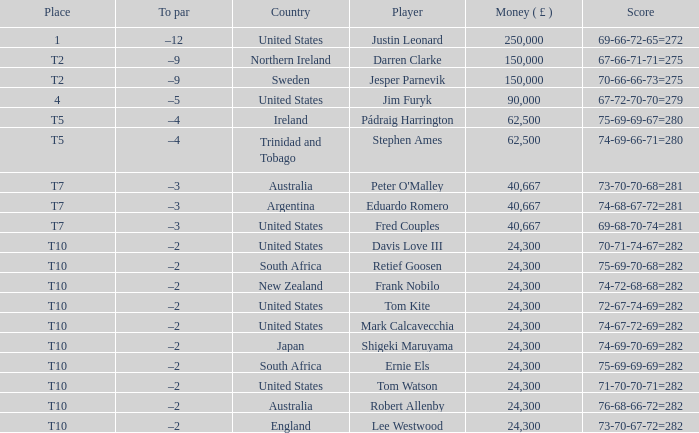What is the money won by Frank Nobilo? 1.0. Write the full table. {'header': ['Place', 'To par', 'Country', 'Player', 'Money ( £ )', 'Score'], 'rows': [['1', '–12', 'United States', 'Justin Leonard', '250,000', '69-66-72-65=272'], ['T2', '–9', 'Northern Ireland', 'Darren Clarke', '150,000', '67-66-71-71=275'], ['T2', '–9', 'Sweden', 'Jesper Parnevik', '150,000', '70-66-66-73=275'], ['4', '–5', 'United States', 'Jim Furyk', '90,000', '67-72-70-70=279'], ['T5', '–4', 'Ireland', 'Pádraig Harrington', '62,500', '75-69-69-67=280'], ['T5', '–4', 'Trinidad and Tobago', 'Stephen Ames', '62,500', '74-69-66-71=280'], ['T7', '–3', 'Australia', "Peter O'Malley", '40,667', '73-70-70-68=281'], ['T7', '–3', 'Argentina', 'Eduardo Romero', '40,667', '74-68-67-72=281'], ['T7', '–3', 'United States', 'Fred Couples', '40,667', '69-68-70-74=281'], ['T10', '–2', 'United States', 'Davis Love III', '24,300', '70-71-74-67=282'], ['T10', '–2', 'South Africa', 'Retief Goosen', '24,300', '75-69-70-68=282'], ['T10', '–2', 'New Zealand', 'Frank Nobilo', '24,300', '74-72-68-68=282'], ['T10', '–2', 'United States', 'Tom Kite', '24,300', '72-67-74-69=282'], ['T10', '–2', 'United States', 'Mark Calcavecchia', '24,300', '74-67-72-69=282'], ['T10', '–2', 'Japan', 'Shigeki Maruyama', '24,300', '74-69-70-69=282'], ['T10', '–2', 'South Africa', 'Ernie Els', '24,300', '75-69-69-69=282'], ['T10', '–2', 'United States', 'Tom Watson', '24,300', '71-70-70-71=282'], ['T10', '–2', 'Australia', 'Robert Allenby', '24,300', '76-68-66-72=282'], ['T10', '–2', 'England', 'Lee Westwood', '24,300', '73-70-67-72=282']]} 